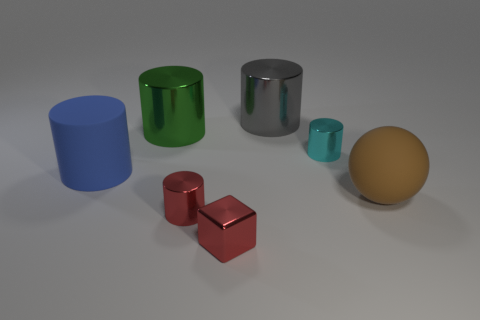What number of shiny things are either red balls or gray things?
Your answer should be very brief. 1. Are there fewer brown things in front of the red block than small red shiny blocks behind the brown thing?
Provide a short and direct response. No. There is a thing on the right side of the small cylinder right of the small cube; is there a blue matte cylinder on the right side of it?
Keep it short and to the point. No. There is a tiny cylinder that is the same color as the cube; what material is it?
Keep it short and to the point. Metal. There is a object on the right side of the cyan shiny cylinder; is it the same shape as the red metallic object that is left of the red cube?
Ensure brevity in your answer.  No. What material is the brown object that is the same size as the green metal cylinder?
Keep it short and to the point. Rubber. Is the material of the large thing that is behind the green shiny cylinder the same as the tiny cylinder that is behind the big blue object?
Provide a succinct answer. Yes. There is a brown matte thing that is the same size as the gray cylinder; what shape is it?
Your answer should be compact. Sphere. What number of other objects are the same color as the small cube?
Give a very brief answer. 1. What is the color of the metal cylinder that is in front of the cyan shiny object?
Offer a very short reply. Red. 